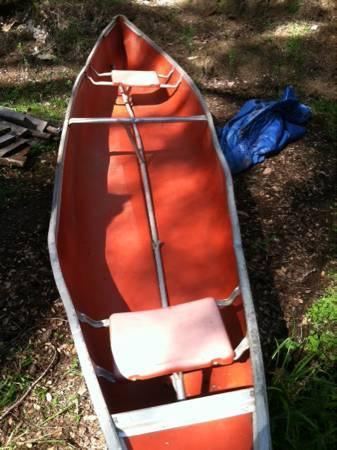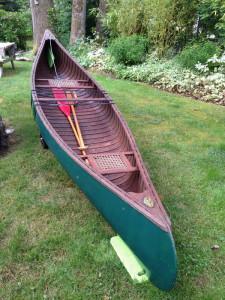The first image is the image on the left, the second image is the image on the right. Given the left and right images, does the statement "In one image, multiple canoes are on an indoor rack, while in the other image, a single canoe is outside." hold true? Answer yes or no. No. The first image is the image on the left, the second image is the image on the right. For the images shown, is this caption "There is at least one green canoe visible" true? Answer yes or no. Yes. 